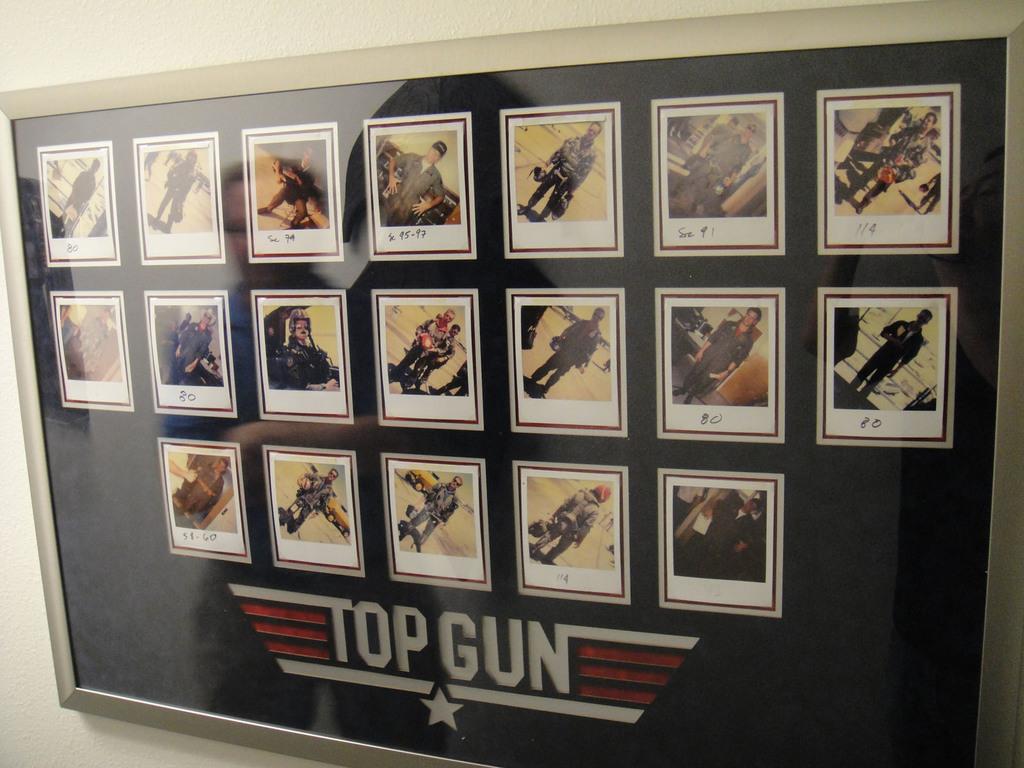The poster is from what movie?
Keep it short and to the point. Top gun. What is written on the picture on the top right?
Your response must be concise. 114. 